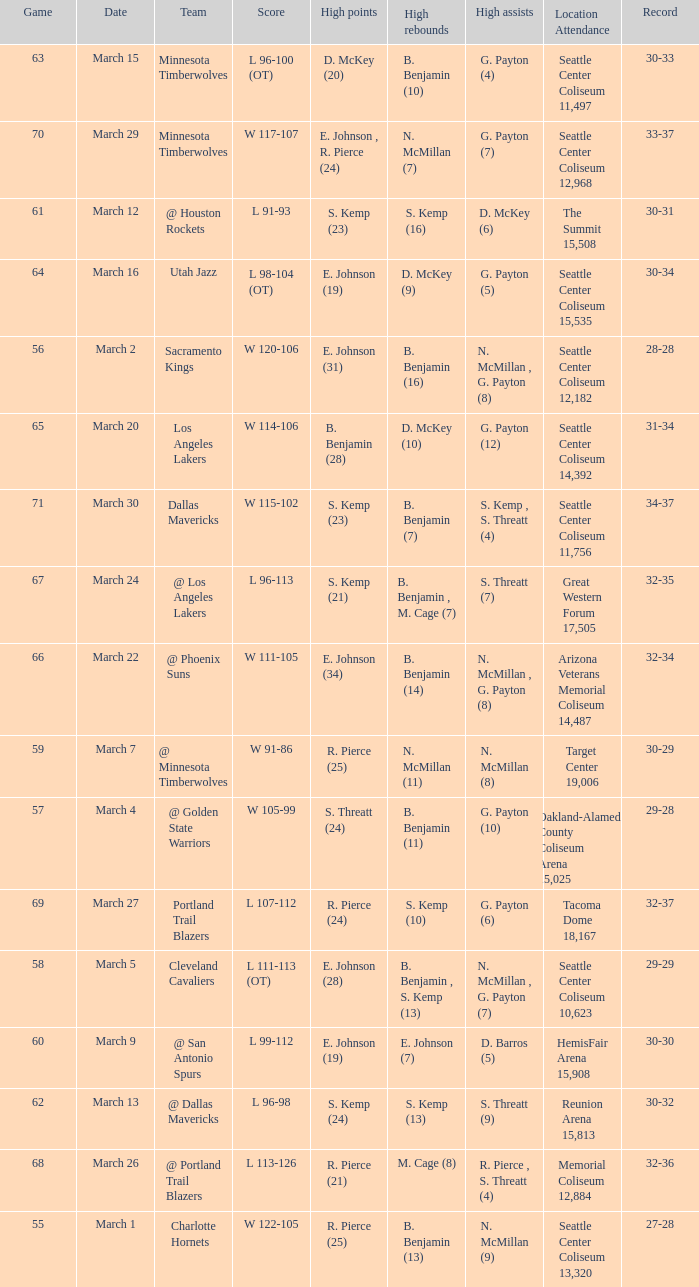Which game was played on march 2? 56.0. 